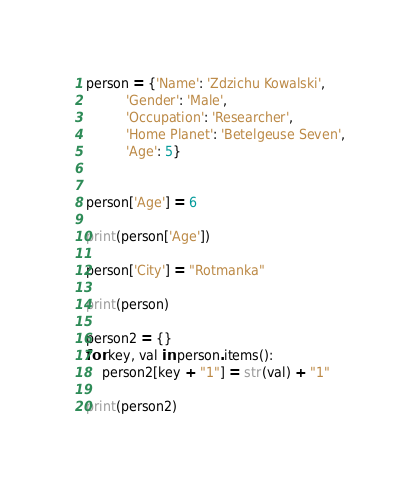<code> <loc_0><loc_0><loc_500><loc_500><_Python_>person = {'Name': 'Zdzichu Kowalski',
          'Gender': 'Male',
          'Occupation': 'Researcher',
          'Home Planet': 'Betelgeuse Seven',
          'Age': 5}


person['Age'] = 6

print(person['Age'])

person['City'] = "Rotmanka"

print(person)

person2 = {}
for key, val in person.items():
    person2[key + "1"] = str(val) + "1"

print(person2)</code> 